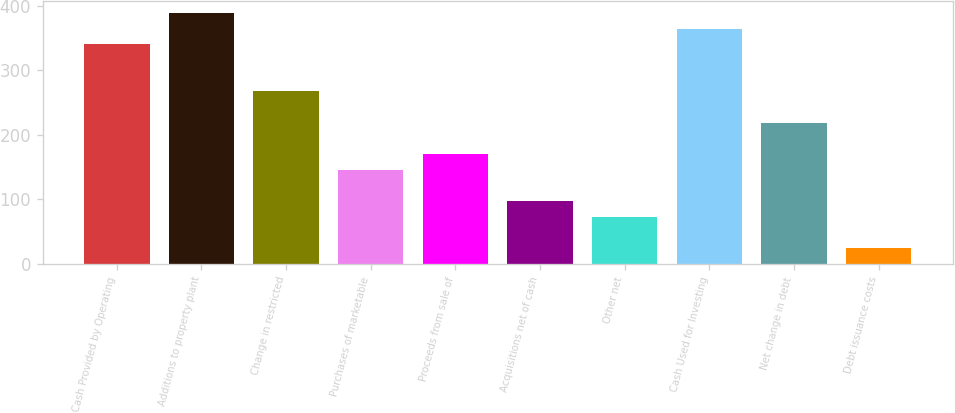Convert chart. <chart><loc_0><loc_0><loc_500><loc_500><bar_chart><fcel>Cash Provided by Operating<fcel>Additions to property plant<fcel>Change in restricted<fcel>Purchases of marketable<fcel>Proceeds from sale of<fcel>Acquisitions net of cash<fcel>Other net<fcel>Cash Used for Investing<fcel>Net change in debt<fcel>Debt issuance costs<nl><fcel>340.1<fcel>388.64<fcel>267.29<fcel>145.94<fcel>170.21<fcel>97.4<fcel>73.13<fcel>364.37<fcel>218.75<fcel>24.59<nl></chart> 